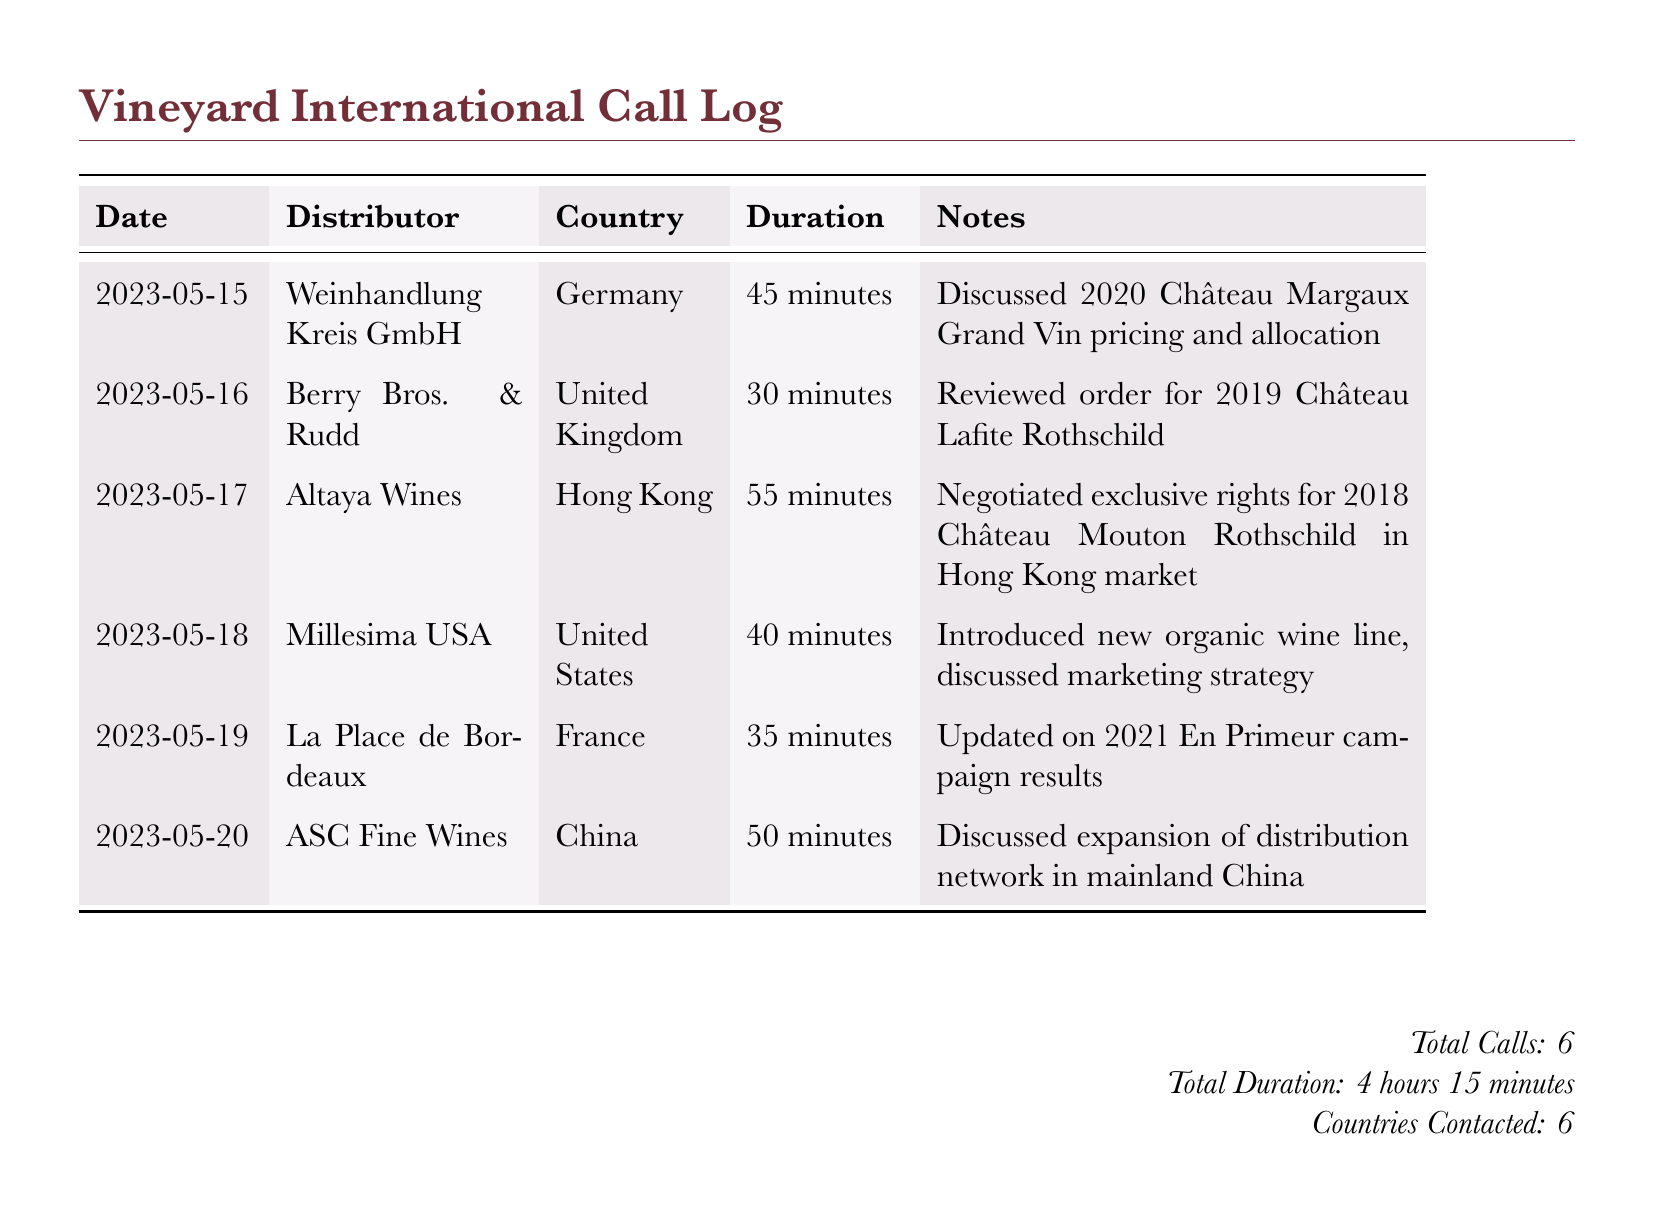What is the date of the call with Weinhandlung Kreis GmbH? The specific date is listed in the first row of the table under the Date column.
Answer: 2023-05-15 How long was the call with the distributor from Hong Kong? The duration of the call with Altaya Wines, the distributor from Hong Kong, is noted in the Duration column.
Answer: 55 minutes Which wine was discussed during the call with Berry Bros. & Rudd? The discussion topic with Berry Bros. & Rudd is described in the Notes column of their entry.
Answer: 2019 Château Lafite Rothschild How many calls were made in total? The total number of calls is summarized at the bottom of the document.
Answer: 6 What was discussed during the call with ASC Fine Wines? The content of the conversation is detailed in the Notes column of the respective entry.
Answer: Expansion of distribution network in mainland China Which country did La Place de Bordeaux represent? La Place de Bordeaux is listed in the Country column associated with their entry in the log.
Answer: France What was the total duration of all calls? The total duration is provided in the summary at the bottom of the document and is calculated based on individual call durations.
Answer: 4 hours 15 minutes Which distributor was contacted about organic wines? The specific distributor discussed in relation to organic wines is stated in the Notes of the call log.
Answer: Millesima USA 